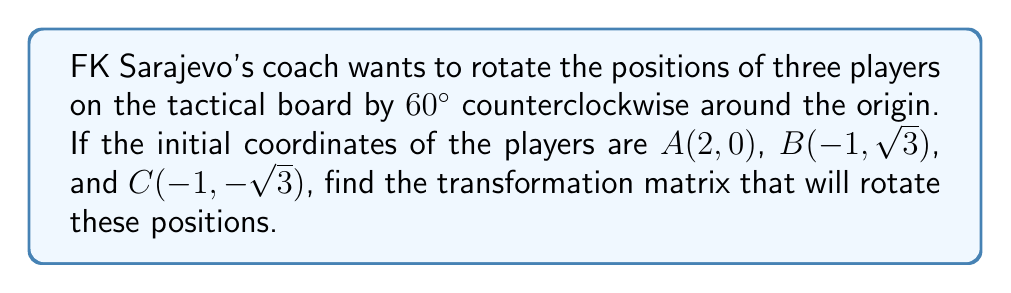Help me with this question. To find the transformation matrix for rotating player positions by 60° counterclockwise, we follow these steps:

1. Recall the general rotation matrix for a counterclockwise rotation by angle θ:
   $$R = \begin{bmatrix} \cos θ & -\sin θ \\ \sin θ & \cos θ \end{bmatrix}$$

2. For a 60° rotation, θ = 60° = π/3 radians. Let's calculate the sine and cosine:
   $\cos 60° = \frac{1}{2}$
   $\sin 60° = \frac{\sqrt{3}}{2}$

3. Substitute these values into the rotation matrix:
   $$R = \begin{bmatrix} \cos 60° & -\sin 60° \\ \sin 60° & \cos 60° \end{bmatrix} = \begin{bmatrix} \frac{1}{2} & -\frac{\sqrt{3}}{2} \\ \frac{\sqrt{3}}{2} & \frac{1}{2} \end{bmatrix}$$

4. This matrix R is the transformation matrix that will rotate the player positions by 60° counterclockwise.

5. To verify, we can apply this matrix to the given points:
   For A(2, 0):
   $$\begin{bmatrix} \frac{1}{2} & -\frac{\sqrt{3}}{2} \\ \frac{\sqrt{3}}{2} & \frac{1}{2} \end{bmatrix} \begin{bmatrix} 2 \\ 0 \end{bmatrix} = \begin{bmatrix} 1 \\ \sqrt{3} \end{bmatrix}$$
   
   For B(-1, √3):
   $$\begin{bmatrix} \frac{1}{2} & -\frac{\sqrt{3}}{2} \\ \frac{\sqrt{3}}{2} & \frac{1}{2} \end{bmatrix} \begin{bmatrix} -1 \\ \sqrt{3} \end{bmatrix} = \begin{bmatrix} -2 \\ 0 \end{bmatrix}$$
   
   For C(-1, -√3):
   $$\begin{bmatrix} \frac{1}{2} & -\frac{\sqrt{3}}{2} \\ \frac{\sqrt{3}}{2} & \frac{1}{2} \end{bmatrix} \begin{bmatrix} -1 \\ -\sqrt{3} \end{bmatrix} = \begin{bmatrix} 1 \\ -\sqrt{3} \end{bmatrix}$$

These new positions confirm a 60° counterclockwise rotation of the original triangle.
Answer: $$R = \begin{bmatrix} \frac{1}{2} & -\frac{\sqrt{3}}{2} \\ \frac{\sqrt{3}}{2} & \frac{1}{2} \end{bmatrix}$$ 